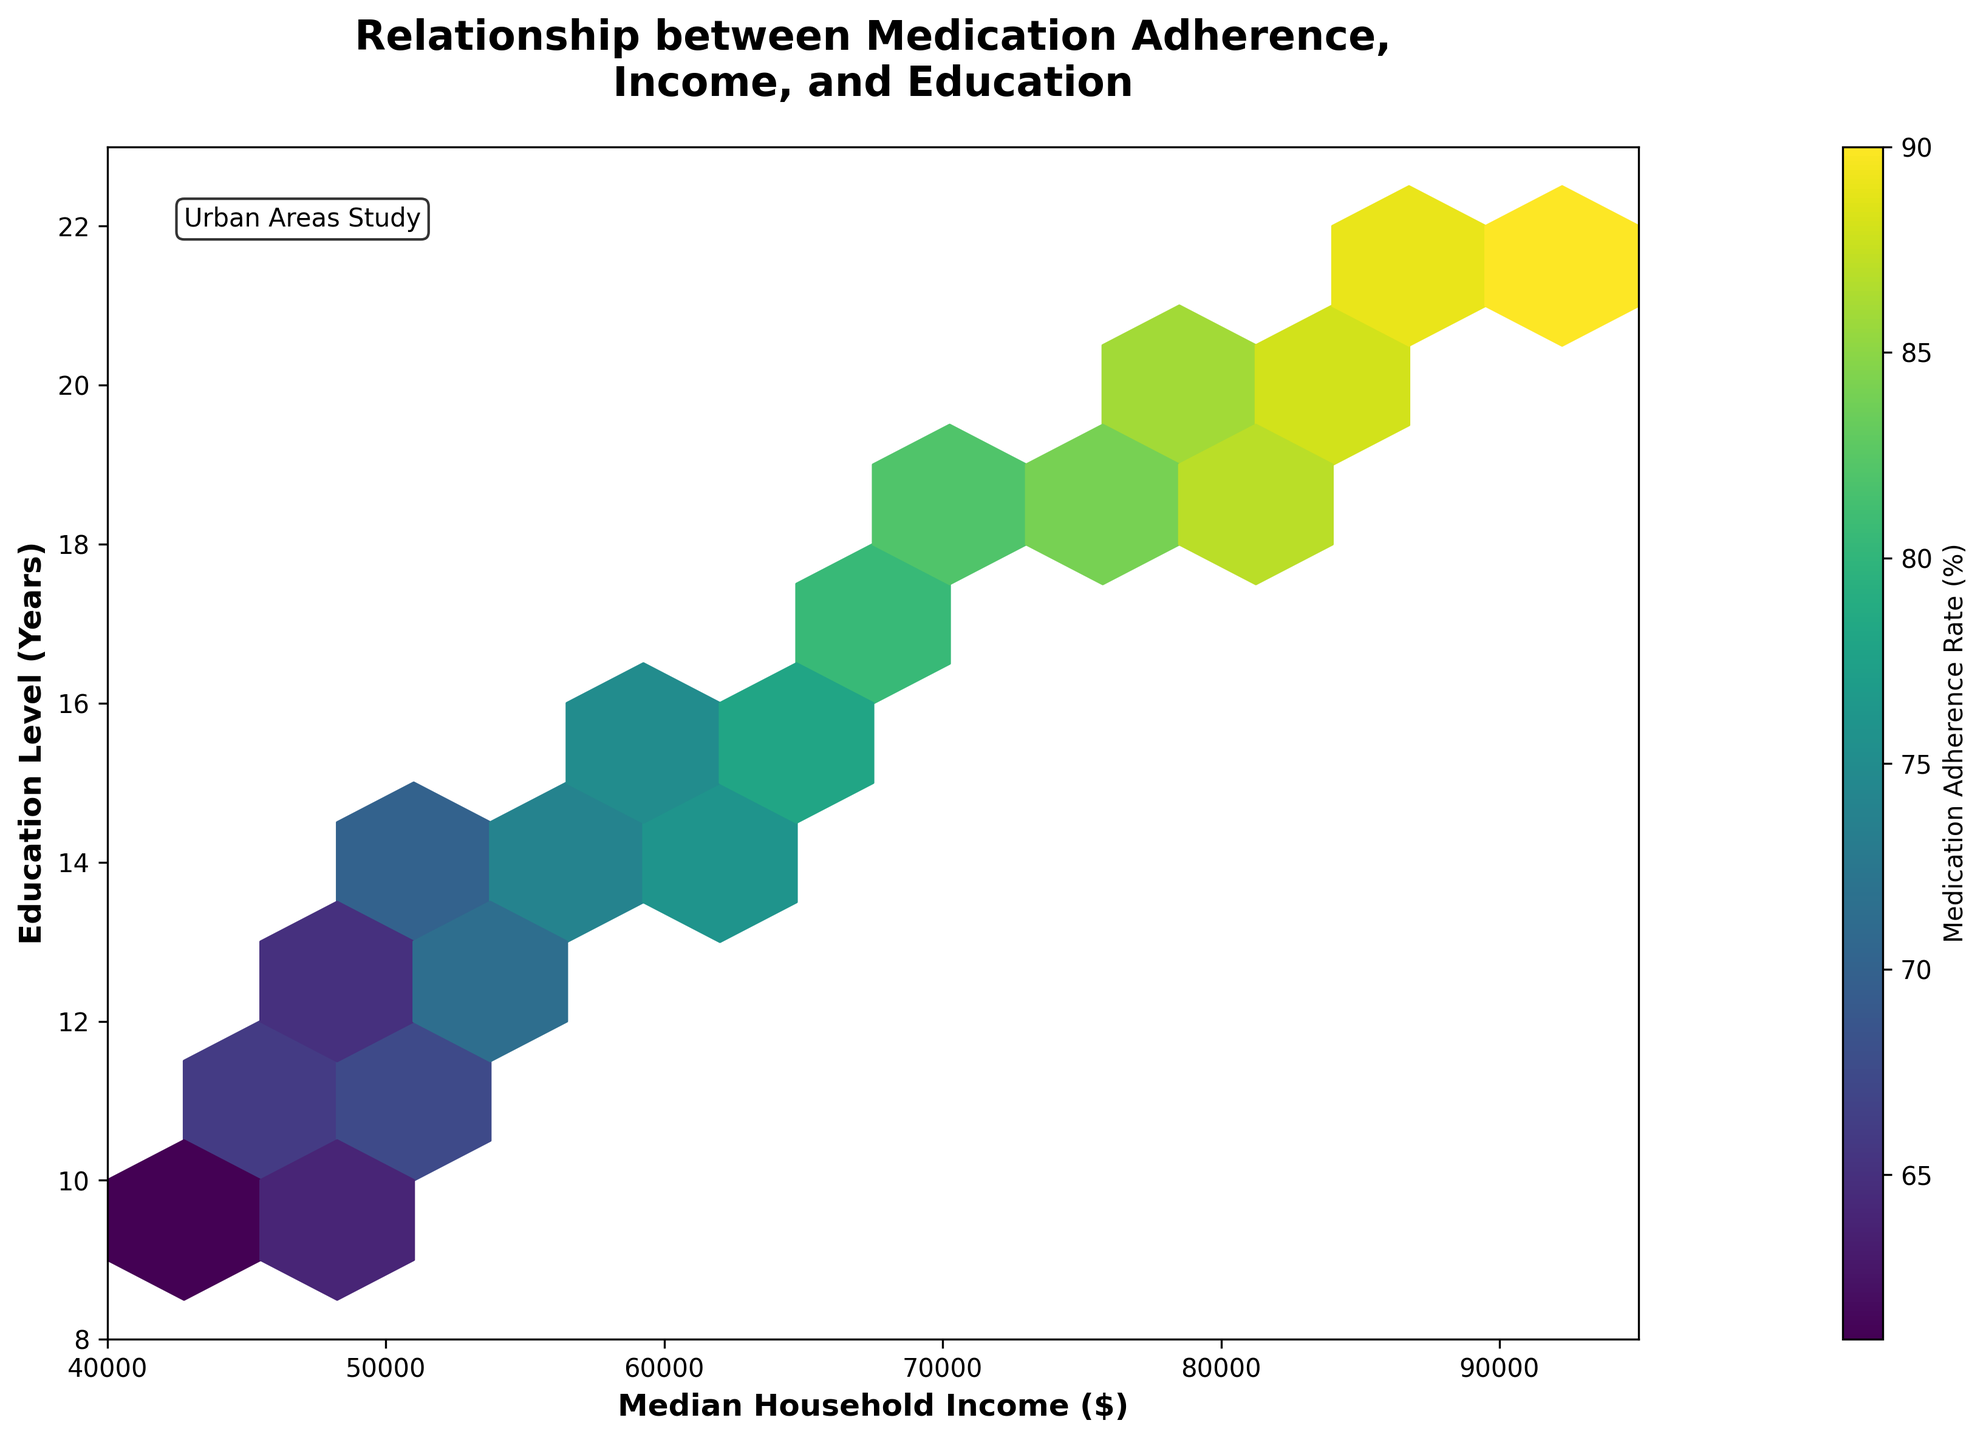What does the color scale represent in the hexbin plot? The color scale in the plot represents the average medication adherence rate (%) for data points within each hexbin cell. Warmer colors indicate higher adherence rates, while cooler colors indicate lower rates.
Answer: Average medication adherence rate What is the x-axis label and its range? The x-axis label is 'Median Household Income ($)', and the range is from $40,000 to $95,000.
Answer: Median Household Income ($), $40,000 to $95,000 What is the relationship between median household income and education level based on the plot? The hexbin plot suggests that higher median household income is generally associated with higher years of education. This can be inferred as the denser hexbin clusters move towards the top-right corner of the plot.
Answer: Positive correlation How does the medication adherence rate change with increasing education levels? The hexbin plot shows that higher education levels are generally associated with higher medical adherence rates. This is evident as the hexbin cells with higher education years (towards the top) tend to have warmer colors, indicating higher adherence rates.
Answer: Increases Are there any hexbin cells representing groups with both low income and low education levels? If so, what are the adherence rates in those areas? Yes, there are hexbin cells in the lower-left corner of the plot representing groups with both low median household income and low education levels. The adherence rates in these areas tend to be lower, as indicated by cooler colors.
Answer: Yes, lower adherence rates What is the most common range of household incomes and education levels based on hexbin density? The most common range seems to be where median household incomes are between $50,000-$70,000 and education levels are between 12-17 years, as indicated by the denser clustering of hexbin cells in these ranges.
Answer: $50,000-$70,000 and 12-17 years Which area shows the highest medication adherence rate? The highest medication adherence rate is in the hexbin cells found in the top-right region of the plot, where both median household income and education levels are high. These cells are represented by the warmest colors.
Answer: Top-right region Does the plot indicate any outliers where education level is high but adherence rate is low or vice versa? The plot does not prominently show any outliers where there is a high education level paired with a low medication adherence rate, or vice versa, as the colors and cluster positions maintain a consistent trend.
Answer: No prominent outliers 